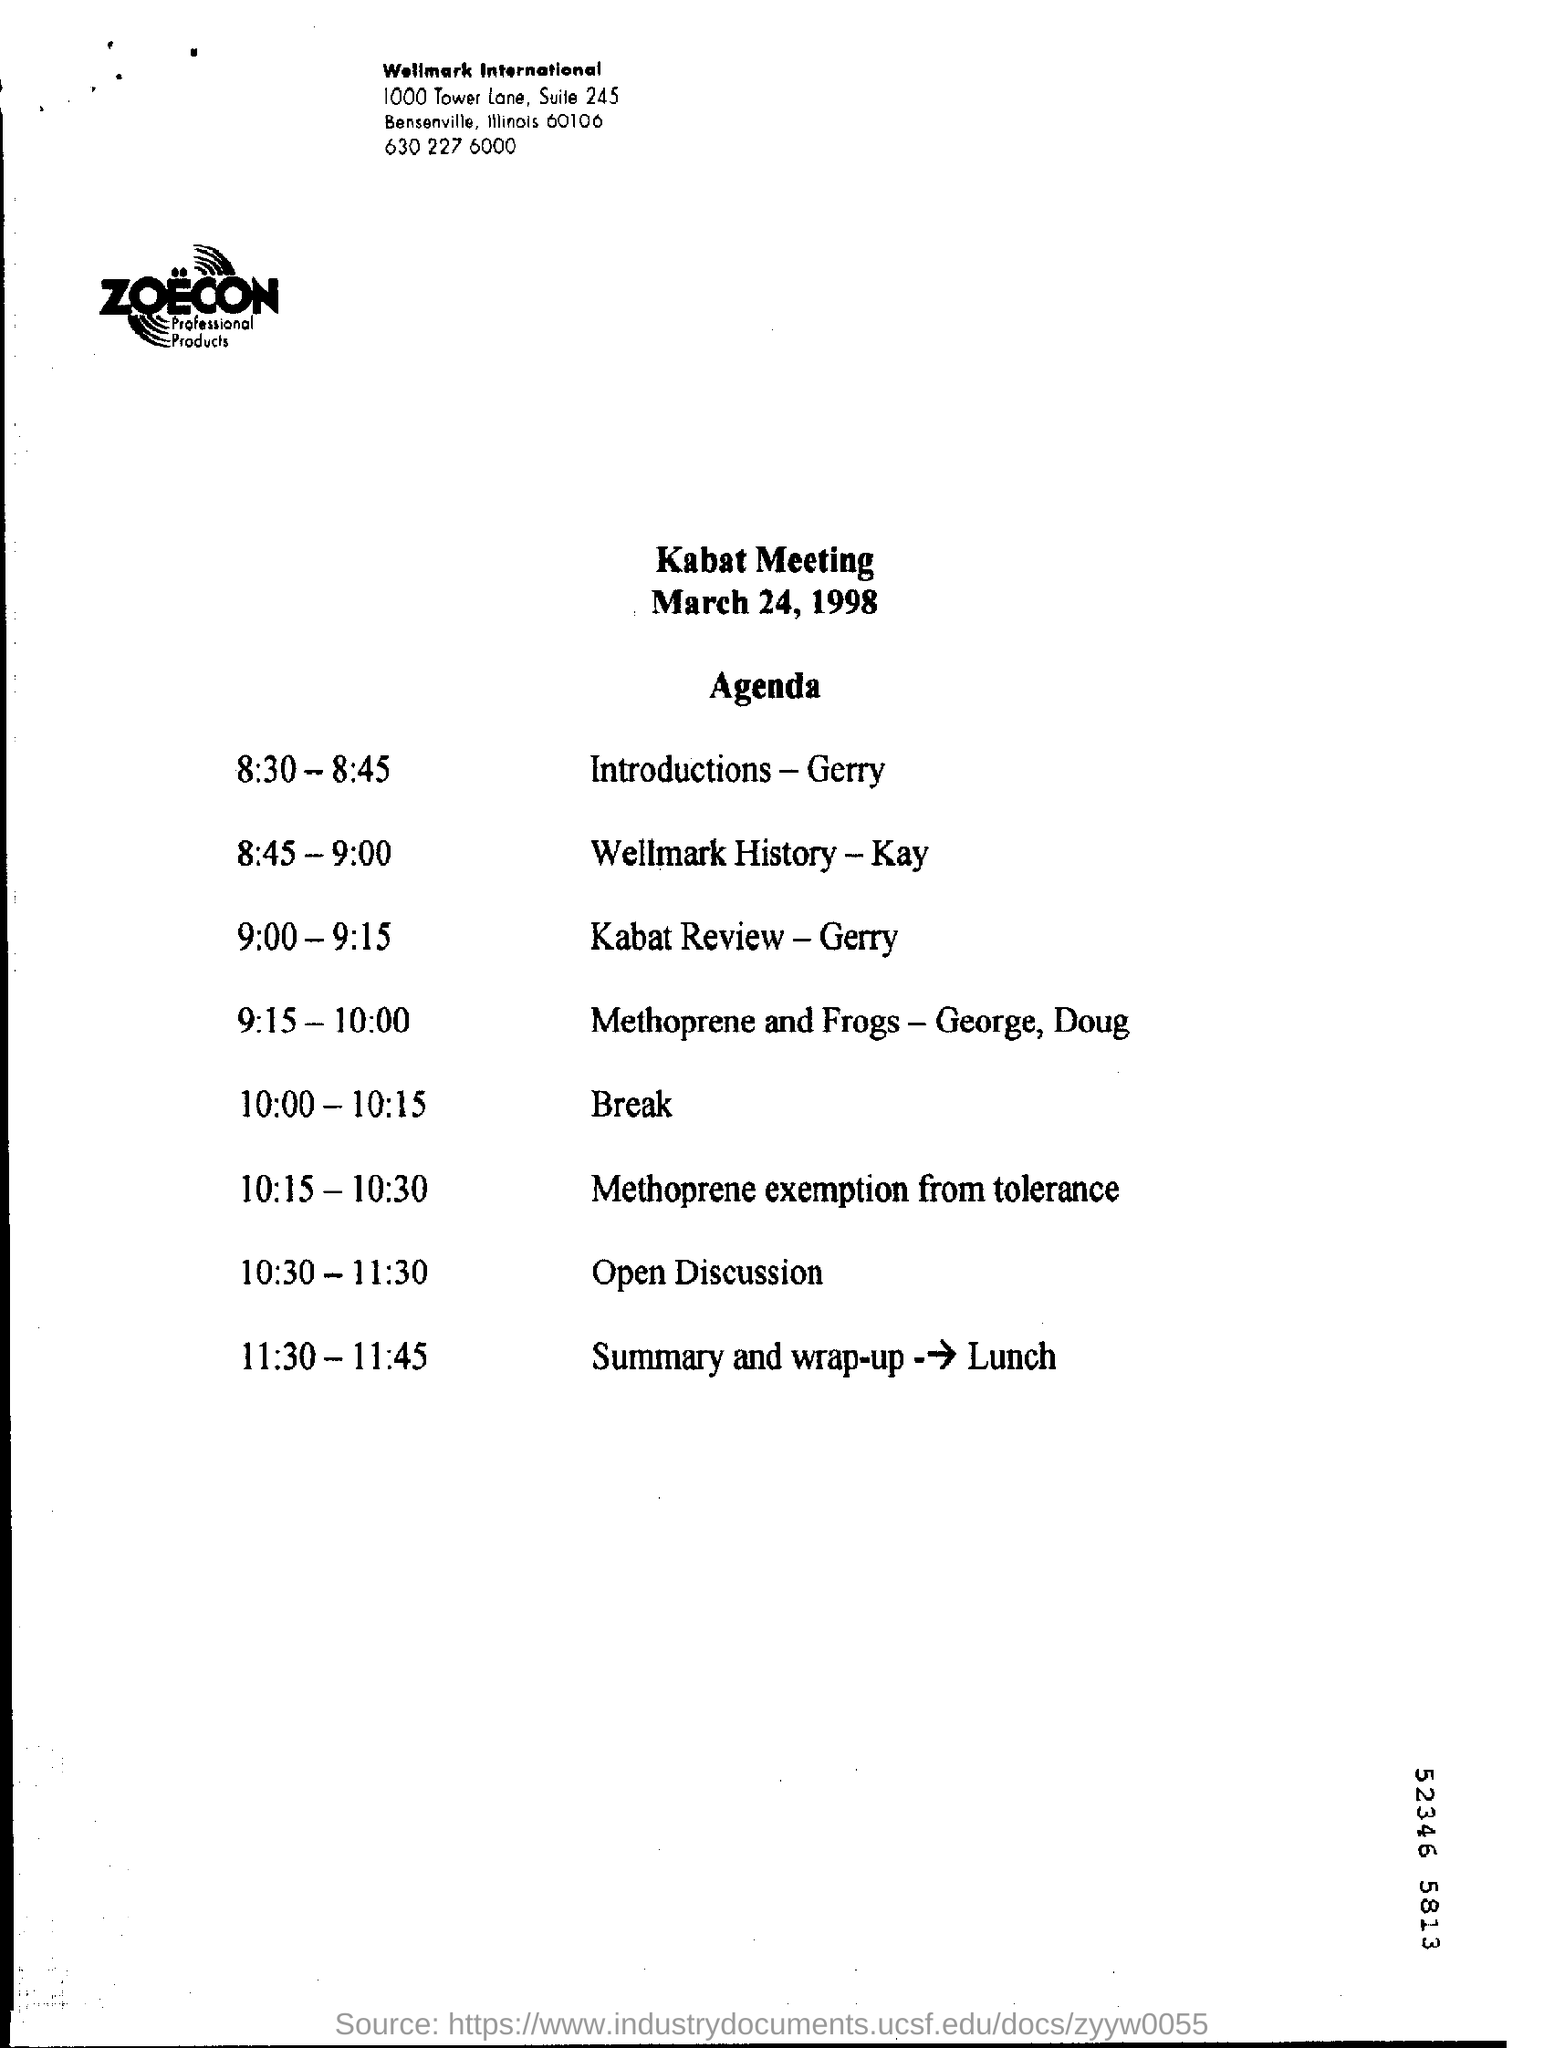What type of meeting is this ?
Make the answer very short. Kabat. What date is the Kabat Meeting scheduled?
Give a very brief answer. March 24, 1998. 